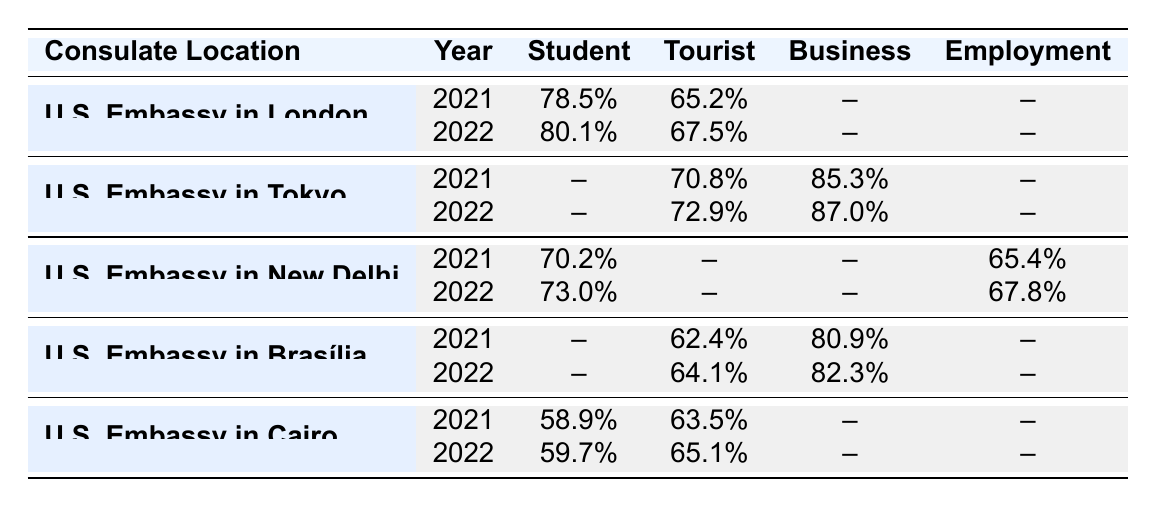What was the approval rate for Student visas at the U.S. Embassy in London in 2021? The table indicates that the approval rate for Student visas at the U.S. Embassy in London in 2021 was 78.5%.
Answer: 78.5% What was the approval rate for Tourist visas at the U.S. Embassy in Tokyo in 2022? Referring to the table, the approval rate for Tourist visas at the U.S. Embassy in Tokyo in 2022 was 72.9%.
Answer: 72.9% Which consulate location had the highest approval rate for Business visas in 2022? The table shows that the U.S. Embassy in Tokyo had the highest approval rate for Business visas in 2022 at 87.0%.
Answer: U.S. Embassy in Tokyo Did the approval rate for Student visas at the U.S. Embassy in Cairo increase from 2021 to 2022? By comparing the table values, the approval rate for Student visas at the U.S. Embassy in Cairo was 58.9% in 2021 and 59.7% in 2022, which is an increase.
Answer: Yes What was the average approval rate for Tourist visas across all consulates in 2021? The approval rates for Tourist visas in 2021 were 65.2% (London), 70.8% (Tokyo), 62.4% (Brasília), and 63.5% (Cairo). Summing these values gives 261.9%, and dividing by 4 provides an average of 65.475%.
Answer: 65.5% Which consulate had the lowest approval rate for Employment visas in 2021? Looking at the table, the U.S. Embassy in New Delhi had an Employment visa approval rate of 65.4% in 2021, while no other consulate had an Employment visa approval rate in that year, making it the only value available.
Answer: U.S. Embassy in New Delhi Is there any consulate that had an equal or higher approval rate for Tourist visas in 2022 compared to 2021? In 2021, the approval rates for Tourist visas were 65.2% (London), 70.8% (Tokyo), 62.4% (Brasília), and 63.5% (Cairo), while in 2022, the rates were 67.5% (London), 72.9% (Tokyo), 64.1% (Brasília), and 65.1% (Cairo). Comparing the years results in the conclusion that all consulates improved their approval rates in 2022 compared to 2021.
Answer: Yes What is the difference in the approval rate for Employment visas between 2021 and 2022 at the U.S. Embassy in New Delhi? The approval rate for Employment visas at the U.S. Embassy in New Delhi was 65.4% in 2021 and increased to 67.8% in 2022. The difference is 67.8% - 65.4% = 2.4%.
Answer: 2.4% What was the overall approval rate for Business visas in 2021 and 2022? In 2021, the Business visa approval rates were 85.3% (Tokyo) and 80.9% (Brasília), totaling 166.2%. In 2022, the rates were 87.0% (Tokyo) and 82.3% (Brasília), totaling 169.3%. The average for both years is 166.2% / 2 = 83.1% for 2021 and 169.3% / 2 = 84.65% for 2022.
Answer: 83.1% for 2021, 84.65% for 2022 Which consulate showed the most significant improvement in Tourist visa approval rates from 2021 to 2022? By examining the table, the U.S. Embassy in Tokyo increased its Tourist visa approval rate from 70.8% in 2021 to 72.9% in 2022, representing a rise of 2.1%. The U.S. Embassy in London increased its rate by 2.3%, from 65.2% to 67.5%, indicating that London showed the most substantial improvement.
Answer: U.S. Embassy in London 